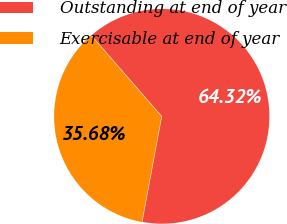Convert chart to OTSL. <chart><loc_0><loc_0><loc_500><loc_500><pie_chart><fcel>Outstanding at end of year<fcel>Exercisable at end of year<nl><fcel>64.32%<fcel>35.68%<nl></chart> 